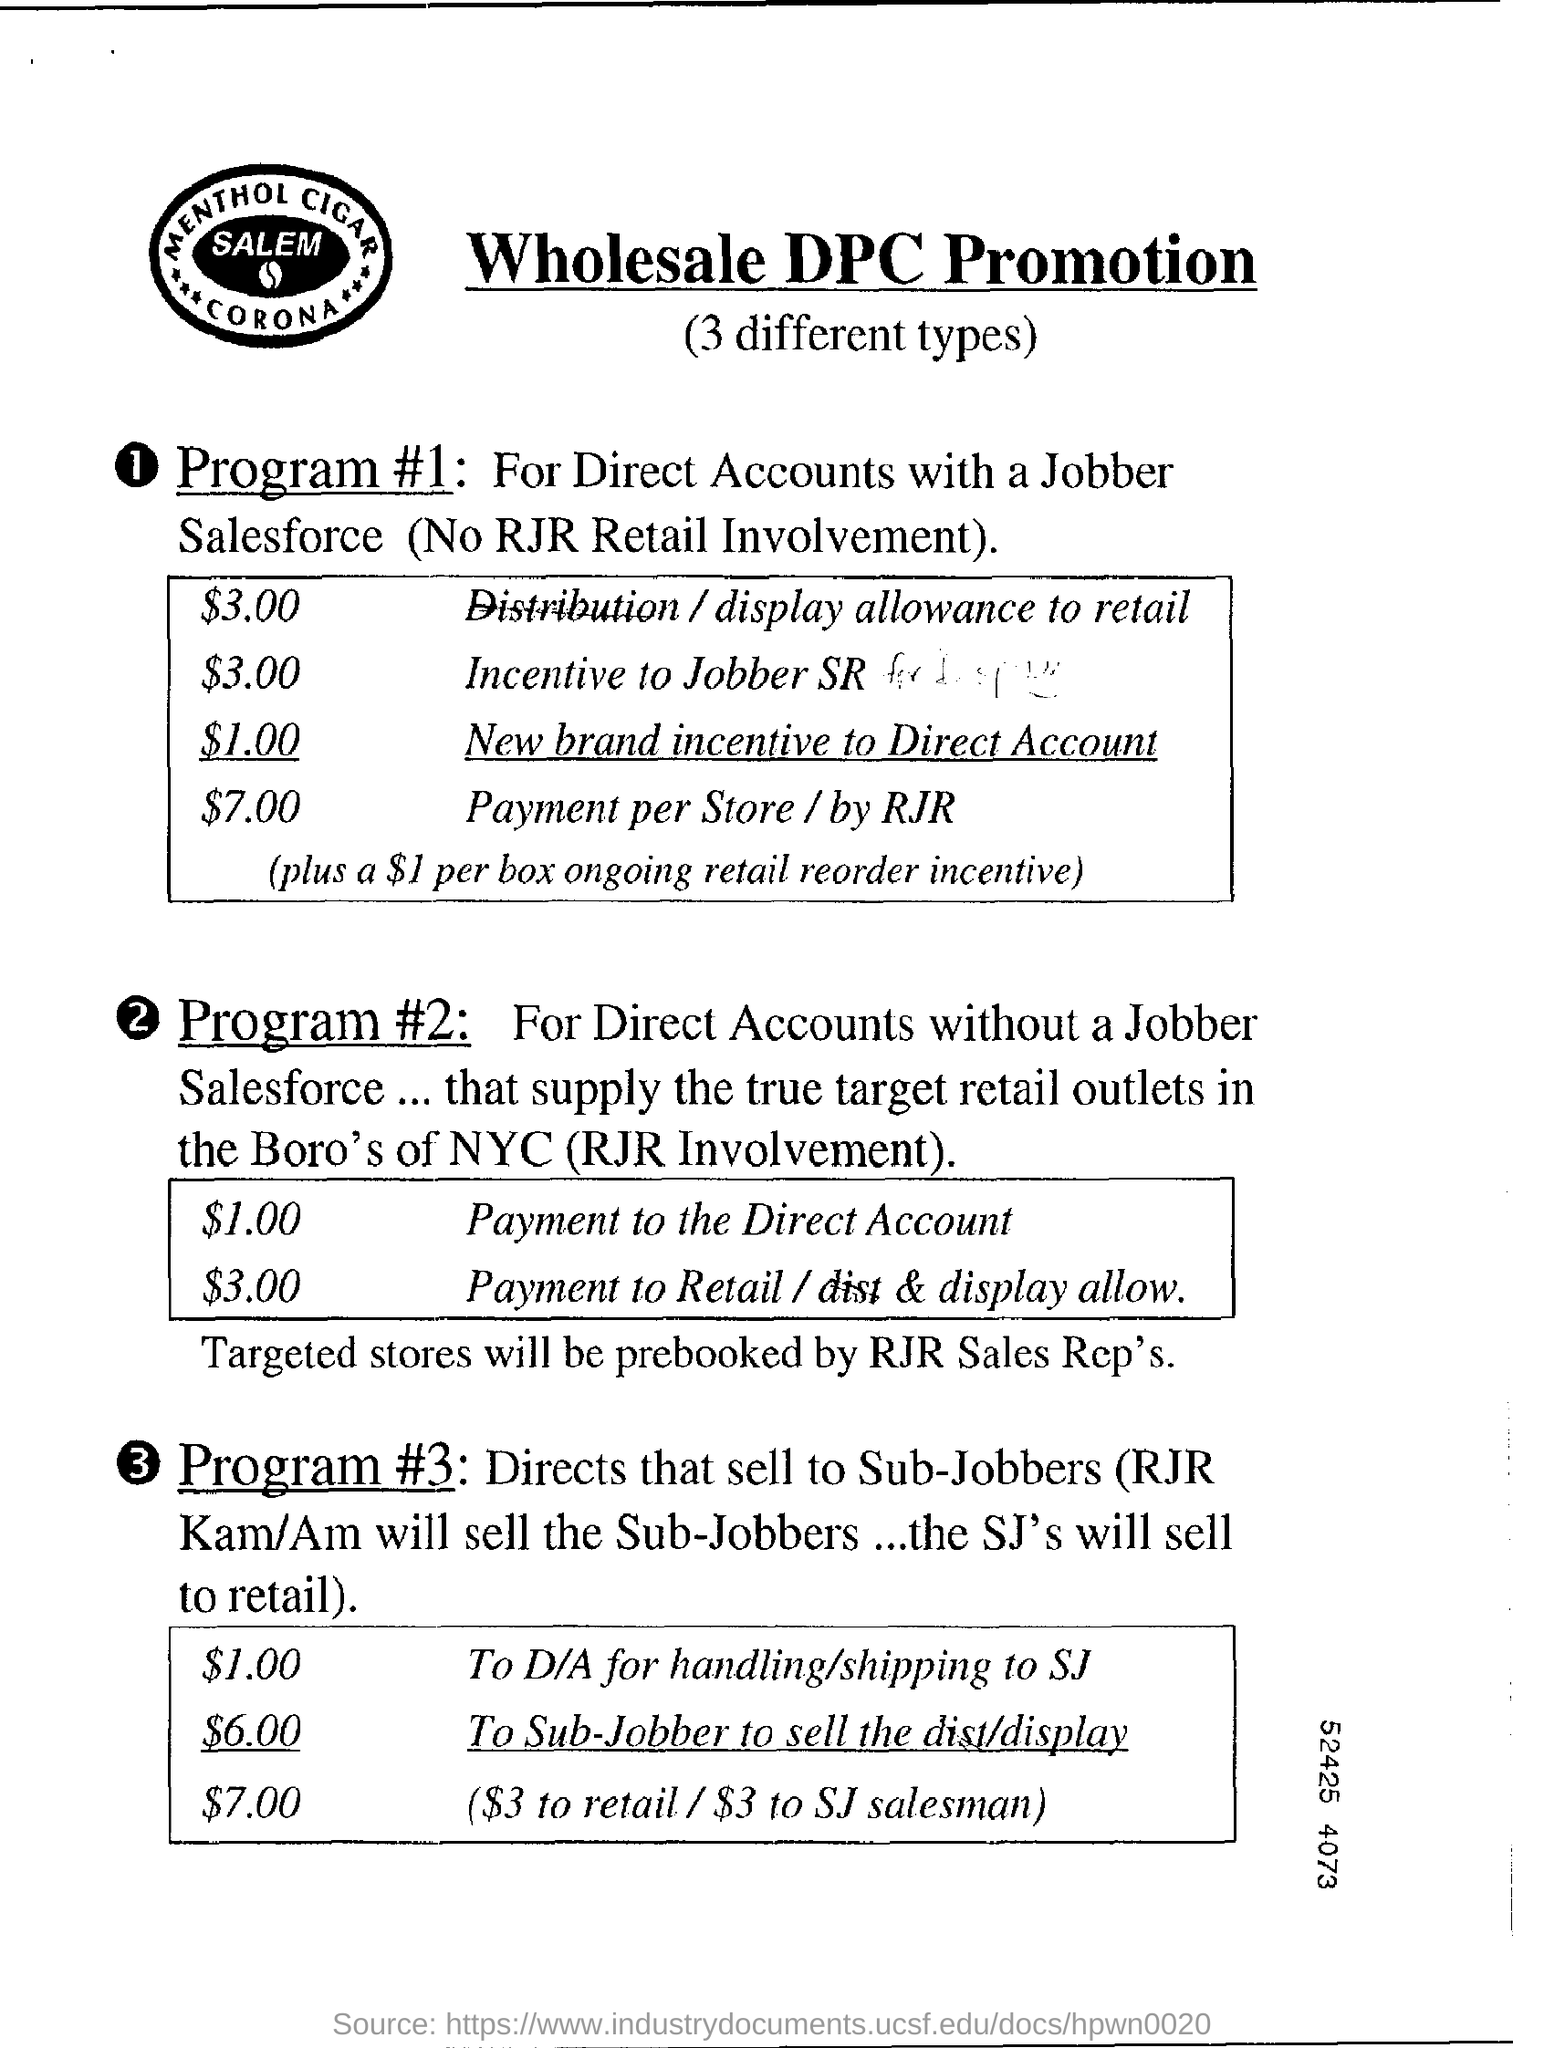List a handful of essential elements in this visual. The cost for handling and shipping to San Jose is $1.00. I have received a new brand incentive to directly account for $1.00. The title of the document is "What is the Title of the document? Wholesale DPC Promotion.. The incentive for joining the jobber SR is $3.00. The cost for a Sub-Jobber to sell a display is $6.00. 